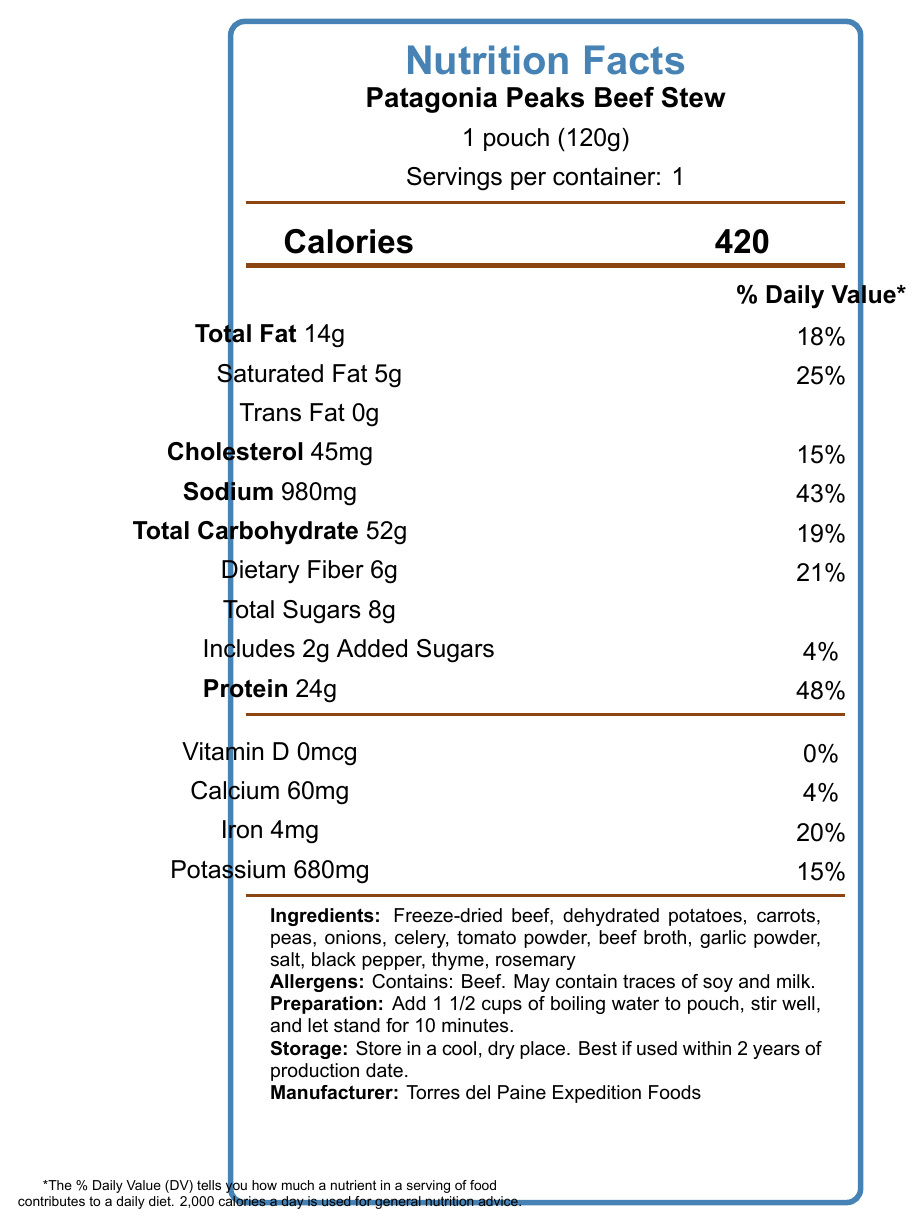what is the serving size of the Patagonia Peaks Beef Stew? The serving size is stated as "1 pouch (120g)" in the document.
Answer: 1 pouch (120g) how many calories are there per serving? The document specifies that there are 420 calories per serving.
Answer: 420 what is the daily value percentage of sodium? The sodium content is listed as 980mg, which is 43% of the daily value.
Answer: 43% what is the preparation method for the beef stew? The preparation instructions are found in the document, stating to add 1 1/2 cups of boiling water, stir well, and let stand for 10 minutes.
Answer: Add 1 1/2 cups of boiling water to pouch, stir well, and let stand for 10 minutes. how much protein is in a serving of this beef stew? The document lists the protein content as 24g per serving.
Answer: 24g how much iron does one serving contain? A. 2mg B. 4mg C. 6mg The document indicates that one serving contains 4mg of iron.
Answer: B. 4mg which of the following nutrients has the highest daily value percentage? A. Total Fat B. Sodium C. Protein D. Saturated Fat The document shows that protein has a 48% daily value, which is higher than the other listed nutrients.
Answer: C. Protein does this product contain any allergens? The document states that the product contains beef and may contain traces of soy and milk.
Answer: Yes does the stew contain any vitamin D? The document lists vitamin D as 0mcg, indicating no vitamin D content.
Answer: No what is the overall main idea of the document? The document contains comprehensive information about the beef stew, covering nutrition facts, ingredients, allergens, preparation, storage, manufacturer, and a personal anecdote related to the product's use during trekking.
Answer: This document provides the nutritional information and other details about the Patagonia Peaks Beef Stew dehydrated camping meal, including serving size, calorie content, macronutrients, vitamins and minerals, preparation instructions, storage advice, manufacturer information, and a personal trekking memory associated with the product. what is the specific potation level of added sugars? The document notes that the stew includes 2g of added sugars.
Answer: 2g what is the manufacturer's name? The manufacturer's name is provided as Torres del Paine Expedition Foods in the document.
Answer: Torres del Paine Expedition Foods do the nutrition facts indicate any traces of nuts? The document lists allergens as beef, with possible traces of soy and milk. There is no mention of nuts, so we cannot determine if nuts are present or not.
Answer: Not enough information what is the dietary fiber content per serving? The dietary fiber content is listed as 6g per serving in the document.
Answer: 6g can you store this product in a humid place? The document advises storing the product in a cool, dry place, indicating that a humid place is unsuitable.
Answer: No what is the cholesterol content and its daily value percentage? The document states the cholesterol content as 45mg, which is 15% of the daily value.
Answer: 45mg, 15% 